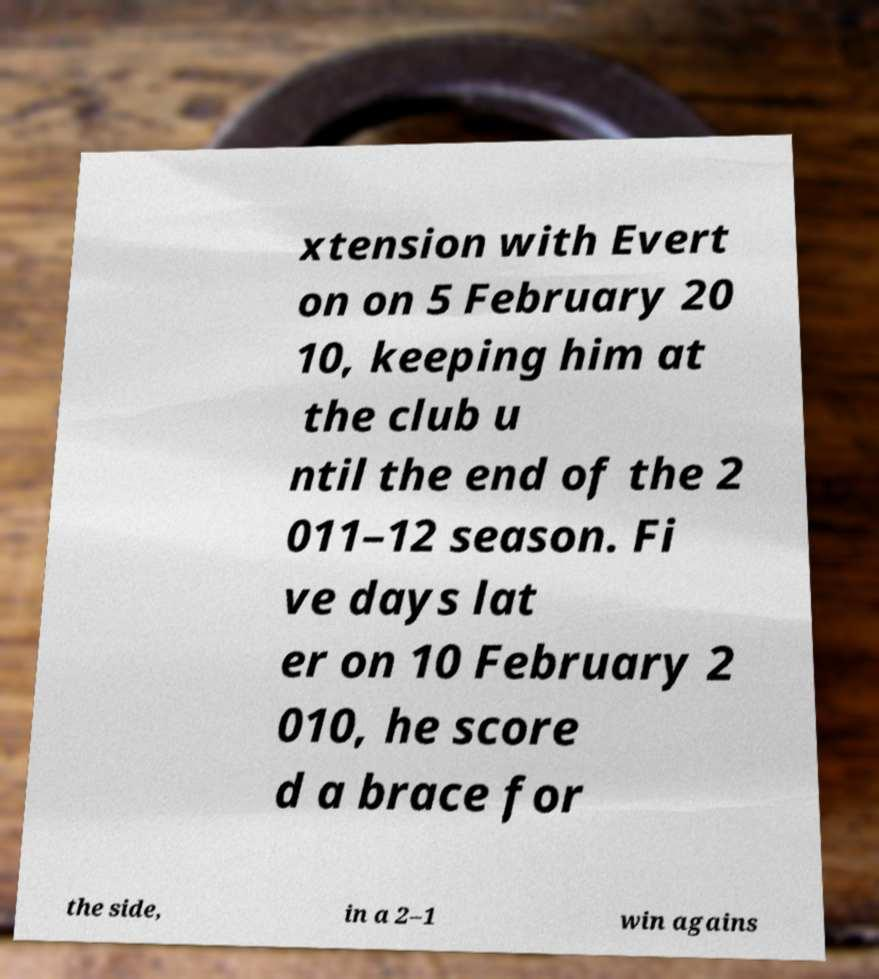Could you assist in decoding the text presented in this image and type it out clearly? xtension with Evert on on 5 February 20 10, keeping him at the club u ntil the end of the 2 011–12 season. Fi ve days lat er on 10 February 2 010, he score d a brace for the side, in a 2–1 win agains 